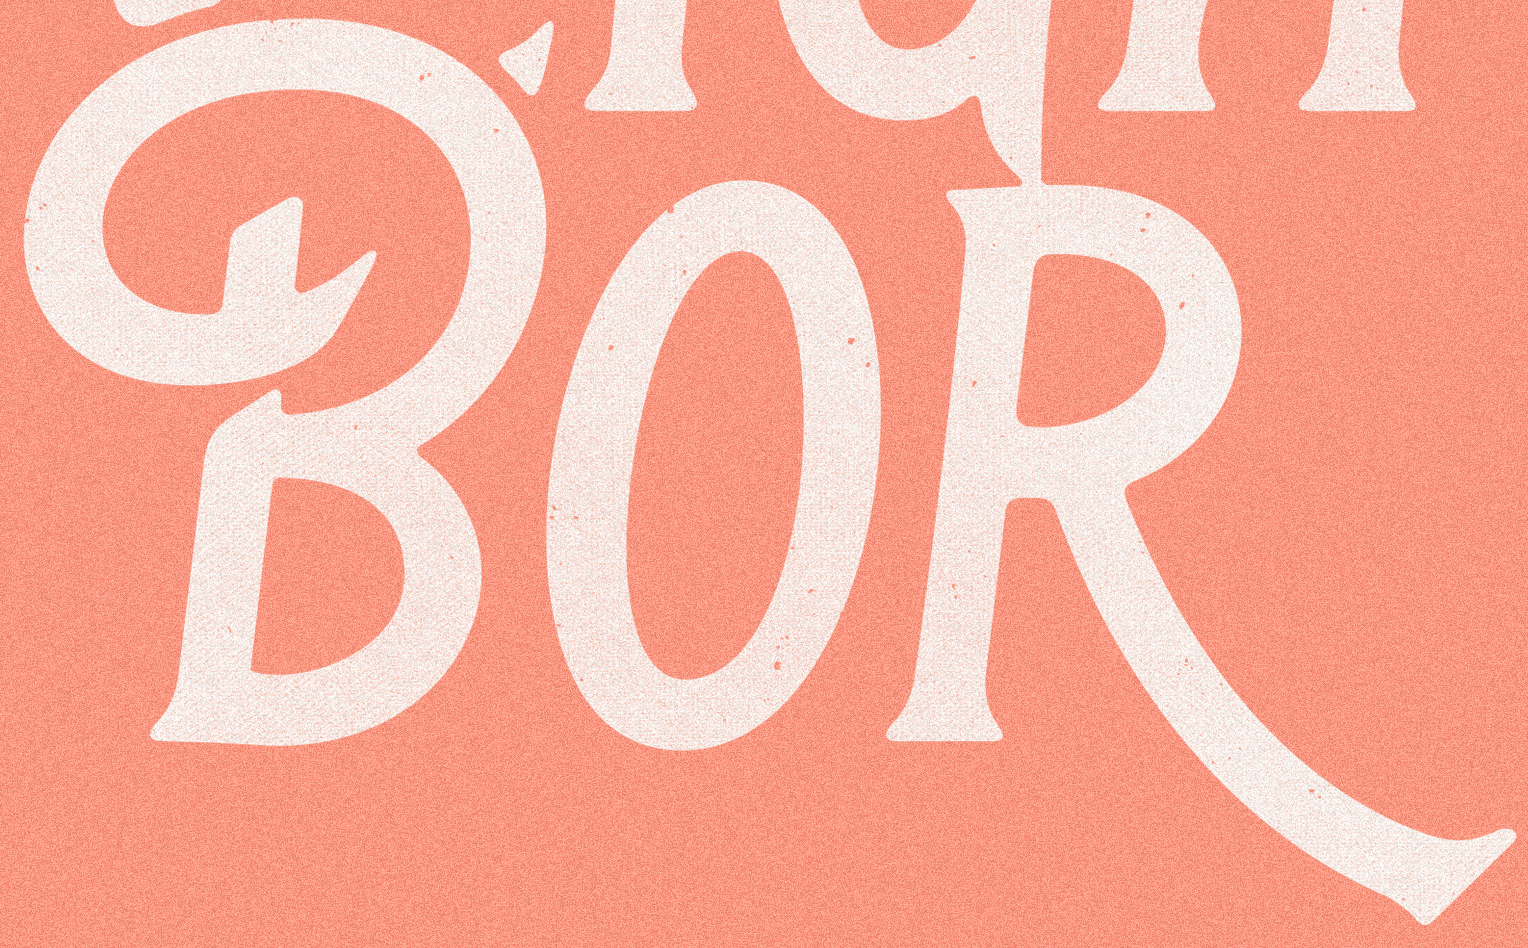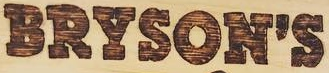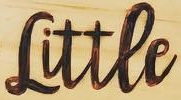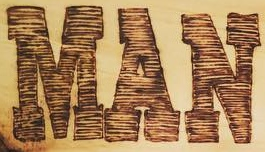What text appears in these images from left to right, separated by a semicolon? BOR; BRYSON'S; Littee; MAN 